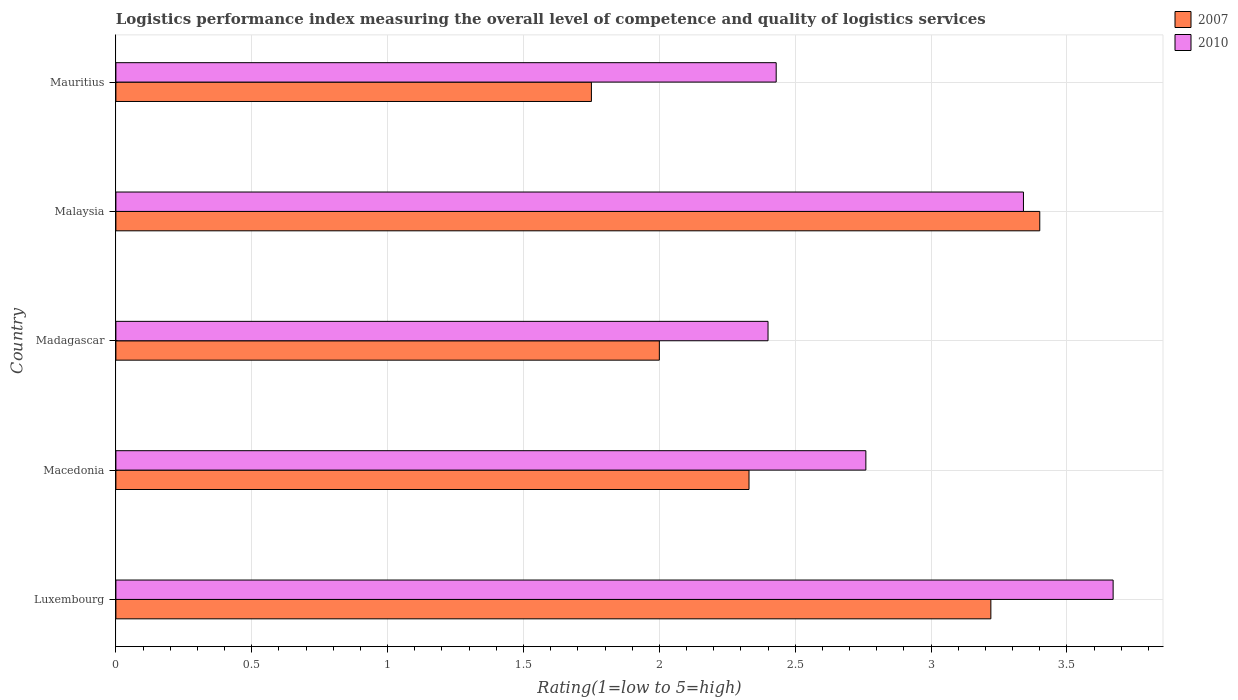How many different coloured bars are there?
Keep it short and to the point. 2. How many groups of bars are there?
Make the answer very short. 5. How many bars are there on the 2nd tick from the top?
Offer a terse response. 2. How many bars are there on the 2nd tick from the bottom?
Your answer should be compact. 2. What is the label of the 3rd group of bars from the top?
Ensure brevity in your answer.  Madagascar. In how many cases, is the number of bars for a given country not equal to the number of legend labels?
Your answer should be very brief. 0. In which country was the Logistic performance index in 2007 maximum?
Make the answer very short. Malaysia. In which country was the Logistic performance index in 2010 minimum?
Offer a terse response. Madagascar. What is the total Logistic performance index in 2007 in the graph?
Keep it short and to the point. 12.7. What is the difference between the Logistic performance index in 2010 in Madagascar and that in Malaysia?
Keep it short and to the point. -0.94. What is the difference between the Logistic performance index in 2010 in Luxembourg and the Logistic performance index in 2007 in Macedonia?
Give a very brief answer. 1.34. What is the average Logistic performance index in 2007 per country?
Ensure brevity in your answer.  2.54. What is the difference between the Logistic performance index in 2010 and Logistic performance index in 2007 in Madagascar?
Your answer should be compact. 0.4. In how many countries, is the Logistic performance index in 2010 greater than 2.3 ?
Provide a short and direct response. 5. What is the ratio of the Logistic performance index in 2007 in Madagascar to that in Malaysia?
Offer a very short reply. 0.59. What is the difference between the highest and the second highest Logistic performance index in 2007?
Your answer should be very brief. 0.18. What is the difference between the highest and the lowest Logistic performance index in 2010?
Provide a succinct answer. 1.27. Is the sum of the Logistic performance index in 2007 in Madagascar and Malaysia greater than the maximum Logistic performance index in 2010 across all countries?
Offer a terse response. Yes. What does the 1st bar from the top in Luxembourg represents?
Make the answer very short. 2010. What does the 2nd bar from the bottom in Malaysia represents?
Make the answer very short. 2010. Are all the bars in the graph horizontal?
Your answer should be compact. Yes. What is the difference between two consecutive major ticks on the X-axis?
Your response must be concise. 0.5. Are the values on the major ticks of X-axis written in scientific E-notation?
Ensure brevity in your answer.  No. Does the graph contain grids?
Offer a very short reply. Yes. Where does the legend appear in the graph?
Ensure brevity in your answer.  Top right. How many legend labels are there?
Keep it short and to the point. 2. What is the title of the graph?
Make the answer very short. Logistics performance index measuring the overall level of competence and quality of logistics services. Does "2008" appear as one of the legend labels in the graph?
Offer a terse response. No. What is the label or title of the X-axis?
Make the answer very short. Rating(1=low to 5=high). What is the label or title of the Y-axis?
Give a very brief answer. Country. What is the Rating(1=low to 5=high) of 2007 in Luxembourg?
Offer a very short reply. 3.22. What is the Rating(1=low to 5=high) in 2010 in Luxembourg?
Offer a terse response. 3.67. What is the Rating(1=low to 5=high) in 2007 in Macedonia?
Your answer should be compact. 2.33. What is the Rating(1=low to 5=high) of 2010 in Macedonia?
Provide a short and direct response. 2.76. What is the Rating(1=low to 5=high) of 2007 in Madagascar?
Provide a succinct answer. 2. What is the Rating(1=low to 5=high) of 2010 in Malaysia?
Your response must be concise. 3.34. What is the Rating(1=low to 5=high) in 2010 in Mauritius?
Provide a succinct answer. 2.43. Across all countries, what is the maximum Rating(1=low to 5=high) in 2007?
Keep it short and to the point. 3.4. Across all countries, what is the maximum Rating(1=low to 5=high) of 2010?
Provide a succinct answer. 3.67. What is the difference between the Rating(1=low to 5=high) in 2007 in Luxembourg and that in Macedonia?
Keep it short and to the point. 0.89. What is the difference between the Rating(1=low to 5=high) of 2010 in Luxembourg and that in Macedonia?
Make the answer very short. 0.91. What is the difference between the Rating(1=low to 5=high) in 2007 in Luxembourg and that in Madagascar?
Provide a short and direct response. 1.22. What is the difference between the Rating(1=low to 5=high) of 2010 in Luxembourg and that in Madagascar?
Your answer should be compact. 1.27. What is the difference between the Rating(1=low to 5=high) in 2007 in Luxembourg and that in Malaysia?
Make the answer very short. -0.18. What is the difference between the Rating(1=low to 5=high) in 2010 in Luxembourg and that in Malaysia?
Ensure brevity in your answer.  0.33. What is the difference between the Rating(1=low to 5=high) of 2007 in Luxembourg and that in Mauritius?
Provide a succinct answer. 1.47. What is the difference between the Rating(1=low to 5=high) of 2010 in Luxembourg and that in Mauritius?
Keep it short and to the point. 1.24. What is the difference between the Rating(1=low to 5=high) of 2007 in Macedonia and that in Madagascar?
Make the answer very short. 0.33. What is the difference between the Rating(1=low to 5=high) of 2010 in Macedonia and that in Madagascar?
Your response must be concise. 0.36. What is the difference between the Rating(1=low to 5=high) of 2007 in Macedonia and that in Malaysia?
Your response must be concise. -1.07. What is the difference between the Rating(1=low to 5=high) in 2010 in Macedonia and that in Malaysia?
Provide a succinct answer. -0.58. What is the difference between the Rating(1=low to 5=high) of 2007 in Macedonia and that in Mauritius?
Keep it short and to the point. 0.58. What is the difference between the Rating(1=low to 5=high) in 2010 in Macedonia and that in Mauritius?
Offer a terse response. 0.33. What is the difference between the Rating(1=low to 5=high) of 2007 in Madagascar and that in Malaysia?
Your answer should be compact. -1.4. What is the difference between the Rating(1=low to 5=high) in 2010 in Madagascar and that in Malaysia?
Your response must be concise. -0.94. What is the difference between the Rating(1=low to 5=high) of 2007 in Madagascar and that in Mauritius?
Your answer should be compact. 0.25. What is the difference between the Rating(1=low to 5=high) in 2010 in Madagascar and that in Mauritius?
Provide a succinct answer. -0.03. What is the difference between the Rating(1=low to 5=high) in 2007 in Malaysia and that in Mauritius?
Your answer should be compact. 1.65. What is the difference between the Rating(1=low to 5=high) in 2010 in Malaysia and that in Mauritius?
Give a very brief answer. 0.91. What is the difference between the Rating(1=low to 5=high) of 2007 in Luxembourg and the Rating(1=low to 5=high) of 2010 in Macedonia?
Offer a terse response. 0.46. What is the difference between the Rating(1=low to 5=high) in 2007 in Luxembourg and the Rating(1=low to 5=high) in 2010 in Madagascar?
Offer a very short reply. 0.82. What is the difference between the Rating(1=low to 5=high) of 2007 in Luxembourg and the Rating(1=low to 5=high) of 2010 in Malaysia?
Make the answer very short. -0.12. What is the difference between the Rating(1=low to 5=high) in 2007 in Luxembourg and the Rating(1=low to 5=high) in 2010 in Mauritius?
Ensure brevity in your answer.  0.79. What is the difference between the Rating(1=low to 5=high) of 2007 in Macedonia and the Rating(1=low to 5=high) of 2010 in Madagascar?
Keep it short and to the point. -0.07. What is the difference between the Rating(1=low to 5=high) in 2007 in Macedonia and the Rating(1=low to 5=high) in 2010 in Malaysia?
Your answer should be compact. -1.01. What is the difference between the Rating(1=low to 5=high) in 2007 in Madagascar and the Rating(1=low to 5=high) in 2010 in Malaysia?
Your answer should be very brief. -1.34. What is the difference between the Rating(1=low to 5=high) in 2007 in Madagascar and the Rating(1=low to 5=high) in 2010 in Mauritius?
Your response must be concise. -0.43. What is the difference between the Rating(1=low to 5=high) of 2007 in Malaysia and the Rating(1=low to 5=high) of 2010 in Mauritius?
Keep it short and to the point. 0.97. What is the average Rating(1=low to 5=high) of 2007 per country?
Provide a succinct answer. 2.54. What is the average Rating(1=low to 5=high) of 2010 per country?
Provide a short and direct response. 2.92. What is the difference between the Rating(1=low to 5=high) of 2007 and Rating(1=low to 5=high) of 2010 in Luxembourg?
Ensure brevity in your answer.  -0.45. What is the difference between the Rating(1=low to 5=high) of 2007 and Rating(1=low to 5=high) of 2010 in Macedonia?
Make the answer very short. -0.43. What is the difference between the Rating(1=low to 5=high) in 2007 and Rating(1=low to 5=high) in 2010 in Mauritius?
Provide a short and direct response. -0.68. What is the ratio of the Rating(1=low to 5=high) of 2007 in Luxembourg to that in Macedonia?
Offer a very short reply. 1.38. What is the ratio of the Rating(1=low to 5=high) in 2010 in Luxembourg to that in Macedonia?
Make the answer very short. 1.33. What is the ratio of the Rating(1=low to 5=high) in 2007 in Luxembourg to that in Madagascar?
Keep it short and to the point. 1.61. What is the ratio of the Rating(1=low to 5=high) of 2010 in Luxembourg to that in Madagascar?
Give a very brief answer. 1.53. What is the ratio of the Rating(1=low to 5=high) of 2007 in Luxembourg to that in Malaysia?
Provide a succinct answer. 0.95. What is the ratio of the Rating(1=low to 5=high) in 2010 in Luxembourg to that in Malaysia?
Your response must be concise. 1.1. What is the ratio of the Rating(1=low to 5=high) in 2007 in Luxembourg to that in Mauritius?
Offer a terse response. 1.84. What is the ratio of the Rating(1=low to 5=high) of 2010 in Luxembourg to that in Mauritius?
Keep it short and to the point. 1.51. What is the ratio of the Rating(1=low to 5=high) in 2007 in Macedonia to that in Madagascar?
Your answer should be very brief. 1.17. What is the ratio of the Rating(1=low to 5=high) of 2010 in Macedonia to that in Madagascar?
Give a very brief answer. 1.15. What is the ratio of the Rating(1=low to 5=high) of 2007 in Macedonia to that in Malaysia?
Give a very brief answer. 0.69. What is the ratio of the Rating(1=low to 5=high) of 2010 in Macedonia to that in Malaysia?
Your answer should be compact. 0.83. What is the ratio of the Rating(1=low to 5=high) in 2007 in Macedonia to that in Mauritius?
Offer a terse response. 1.33. What is the ratio of the Rating(1=low to 5=high) in 2010 in Macedonia to that in Mauritius?
Offer a terse response. 1.14. What is the ratio of the Rating(1=low to 5=high) in 2007 in Madagascar to that in Malaysia?
Provide a succinct answer. 0.59. What is the ratio of the Rating(1=low to 5=high) of 2010 in Madagascar to that in Malaysia?
Your response must be concise. 0.72. What is the ratio of the Rating(1=low to 5=high) in 2007 in Madagascar to that in Mauritius?
Keep it short and to the point. 1.14. What is the ratio of the Rating(1=low to 5=high) in 2007 in Malaysia to that in Mauritius?
Provide a short and direct response. 1.94. What is the ratio of the Rating(1=low to 5=high) in 2010 in Malaysia to that in Mauritius?
Your answer should be very brief. 1.37. What is the difference between the highest and the second highest Rating(1=low to 5=high) in 2007?
Make the answer very short. 0.18. What is the difference between the highest and the second highest Rating(1=low to 5=high) in 2010?
Your answer should be very brief. 0.33. What is the difference between the highest and the lowest Rating(1=low to 5=high) of 2007?
Offer a terse response. 1.65. What is the difference between the highest and the lowest Rating(1=low to 5=high) in 2010?
Your response must be concise. 1.27. 